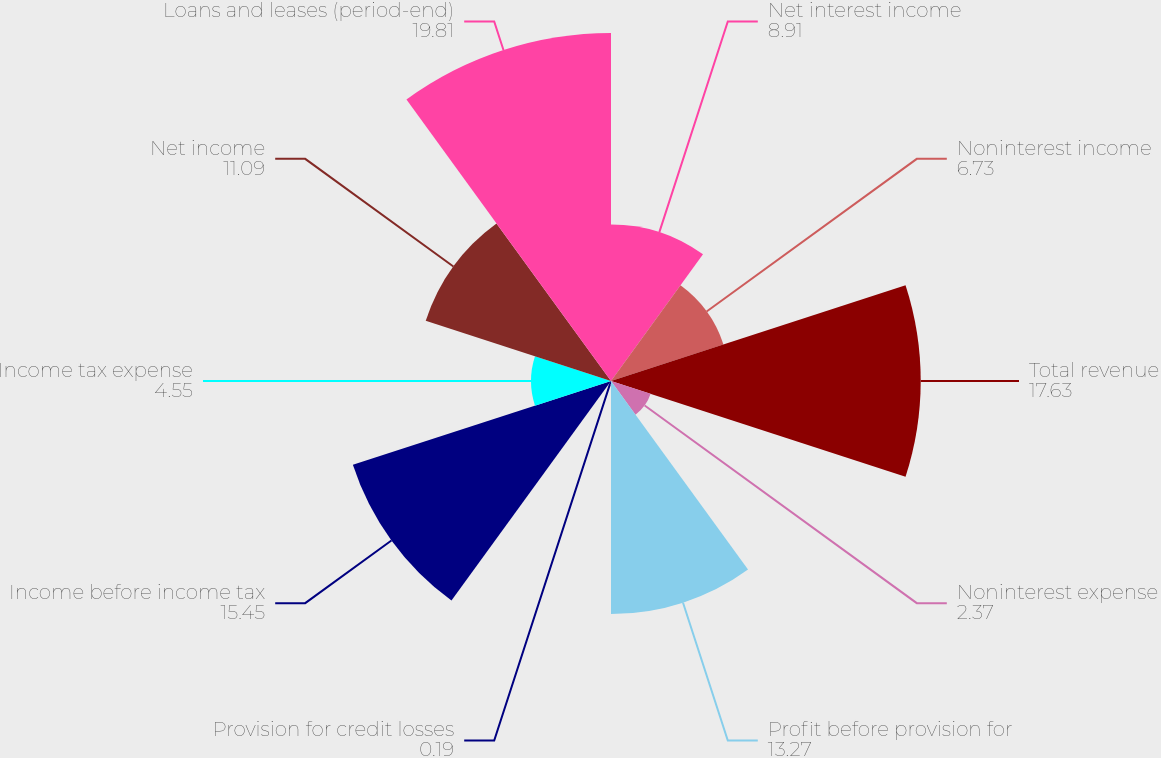Convert chart. <chart><loc_0><loc_0><loc_500><loc_500><pie_chart><fcel>Net interest income<fcel>Noninterest income<fcel>Total revenue<fcel>Noninterest expense<fcel>Profit before provision for<fcel>Provision for credit losses<fcel>Income before income tax<fcel>Income tax expense<fcel>Net income<fcel>Loans and leases (period-end)<nl><fcel>8.91%<fcel>6.73%<fcel>17.63%<fcel>2.37%<fcel>13.27%<fcel>0.19%<fcel>15.45%<fcel>4.55%<fcel>11.09%<fcel>19.81%<nl></chart> 